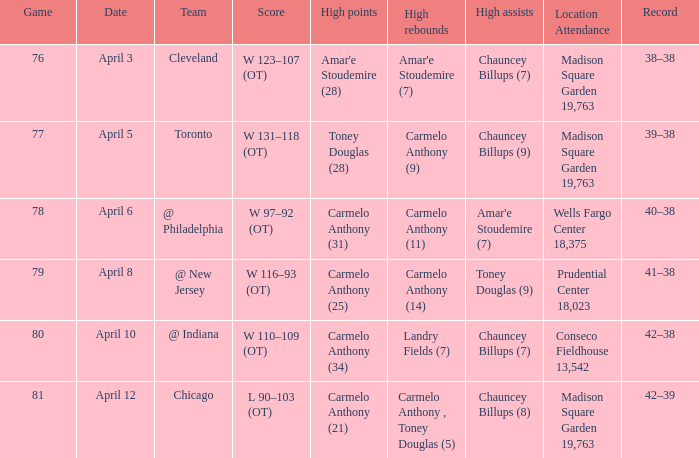What is the date associated with cleveland? April 3. 